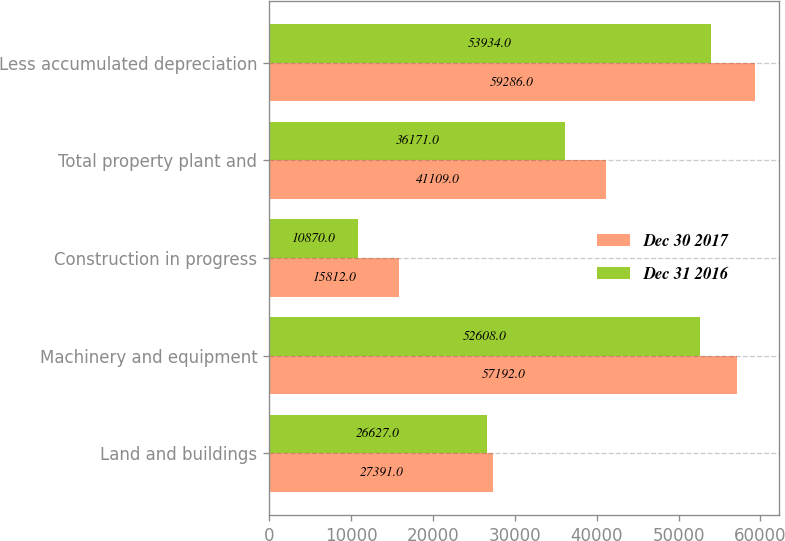Convert chart to OTSL. <chart><loc_0><loc_0><loc_500><loc_500><stacked_bar_chart><ecel><fcel>Land and buildings<fcel>Machinery and equipment<fcel>Construction in progress<fcel>Total property plant and<fcel>Less accumulated depreciation<nl><fcel>Dec 30 2017<fcel>27391<fcel>57192<fcel>15812<fcel>41109<fcel>59286<nl><fcel>Dec 31 2016<fcel>26627<fcel>52608<fcel>10870<fcel>36171<fcel>53934<nl></chart> 